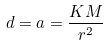Convert formula to latex. <formula><loc_0><loc_0><loc_500><loc_500>d = a = \frac { K M } { r ^ { 2 } }</formula> 